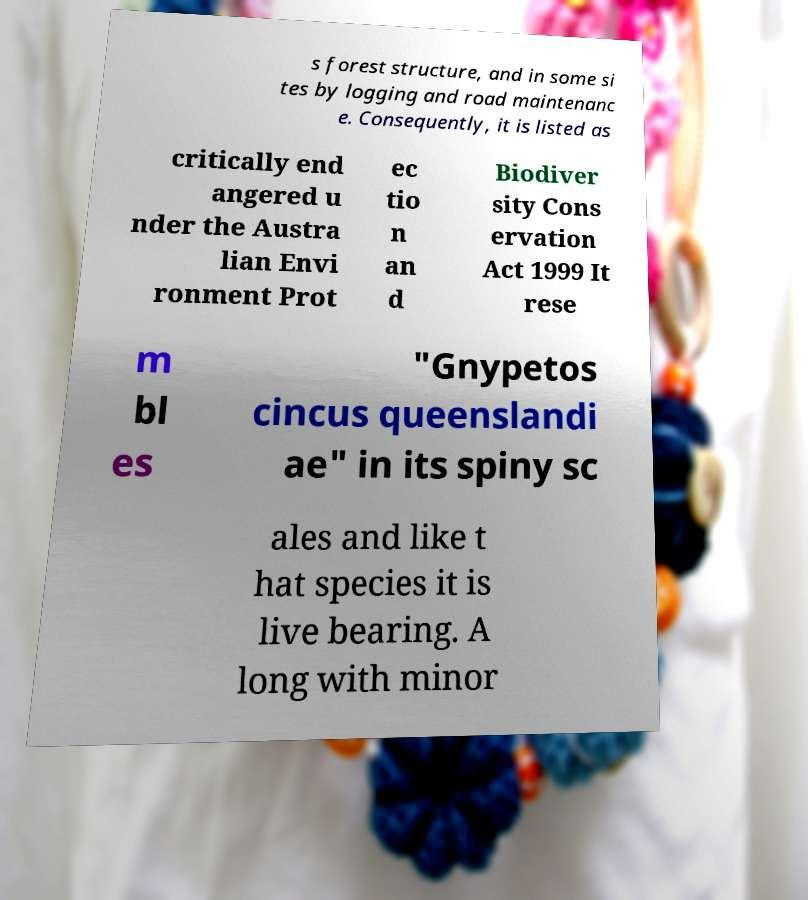Can you accurately transcribe the text from the provided image for me? s forest structure, and in some si tes by logging and road maintenanc e. Consequently, it is listed as critically end angered u nder the Austra lian Envi ronment Prot ec tio n an d Biodiver sity Cons ervation Act 1999 It rese m bl es "Gnypetos cincus queenslandi ae" in its spiny sc ales and like t hat species it is live bearing. A long with minor 